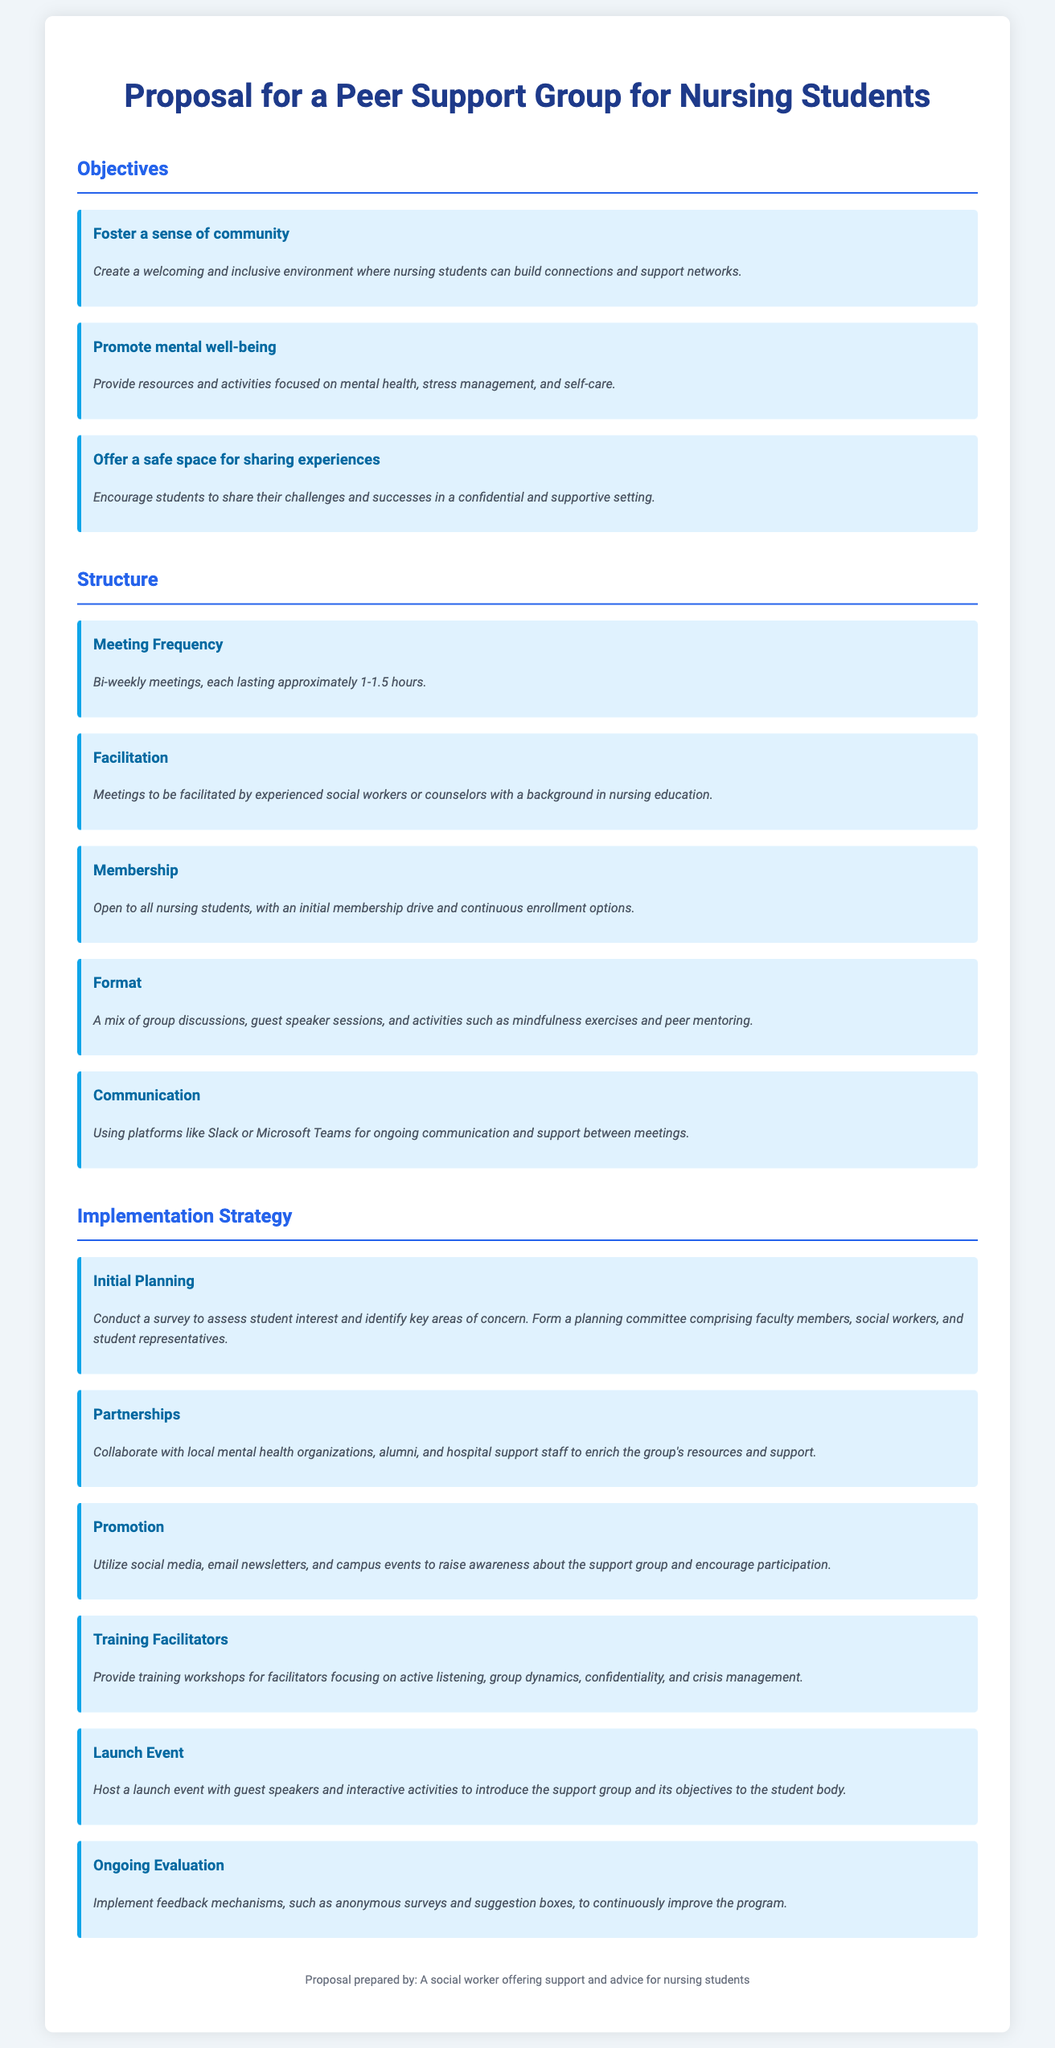what is the main title of the proposal? The main title of the proposal is specified in the document and summarizes the focus on peer support for nursing students.
Answer: Proposal for a Peer Support Group for Nursing Students how often will the meetings occur? Meeting frequency is outlined in the structure section, indicating how often the group will gather.
Answer: Bi-weekly who will facilitate the meetings? The facilitator's role is detailed in the structure section, describing who is responsible for leading the meetings.
Answer: Experienced social workers or counselors what is one of the objectives of the support group? The proposal outlines various goals for the peer support group; a specific objective can be highlighted from the text.
Answer: Foster a sense of community what is the first step in the implementation strategy? The document describes specific steps to put the proposal into action, starting with initial planning.
Answer: Initial Planning how will the group maintain ongoing communication? Communication methods used to support engagement between meetings are mentioned, identifying the platforms for interaction.
Answer: Slack or Microsoft Teams what type of event is planned for the launch? The launch strategy includes a specific type of event to introduce the group to the students.
Answer: Launch event how will feedback be collected for improvement? The document discusses mechanisms for evaluating the support group, which include gathering insights from participants.
Answer: Anonymous surveys and suggestion boxes who prepared the proposal? The document indicates the creator of the proposal, specifying their role related to the nursing students.
Answer: A social worker offering support and advice for nursing students 